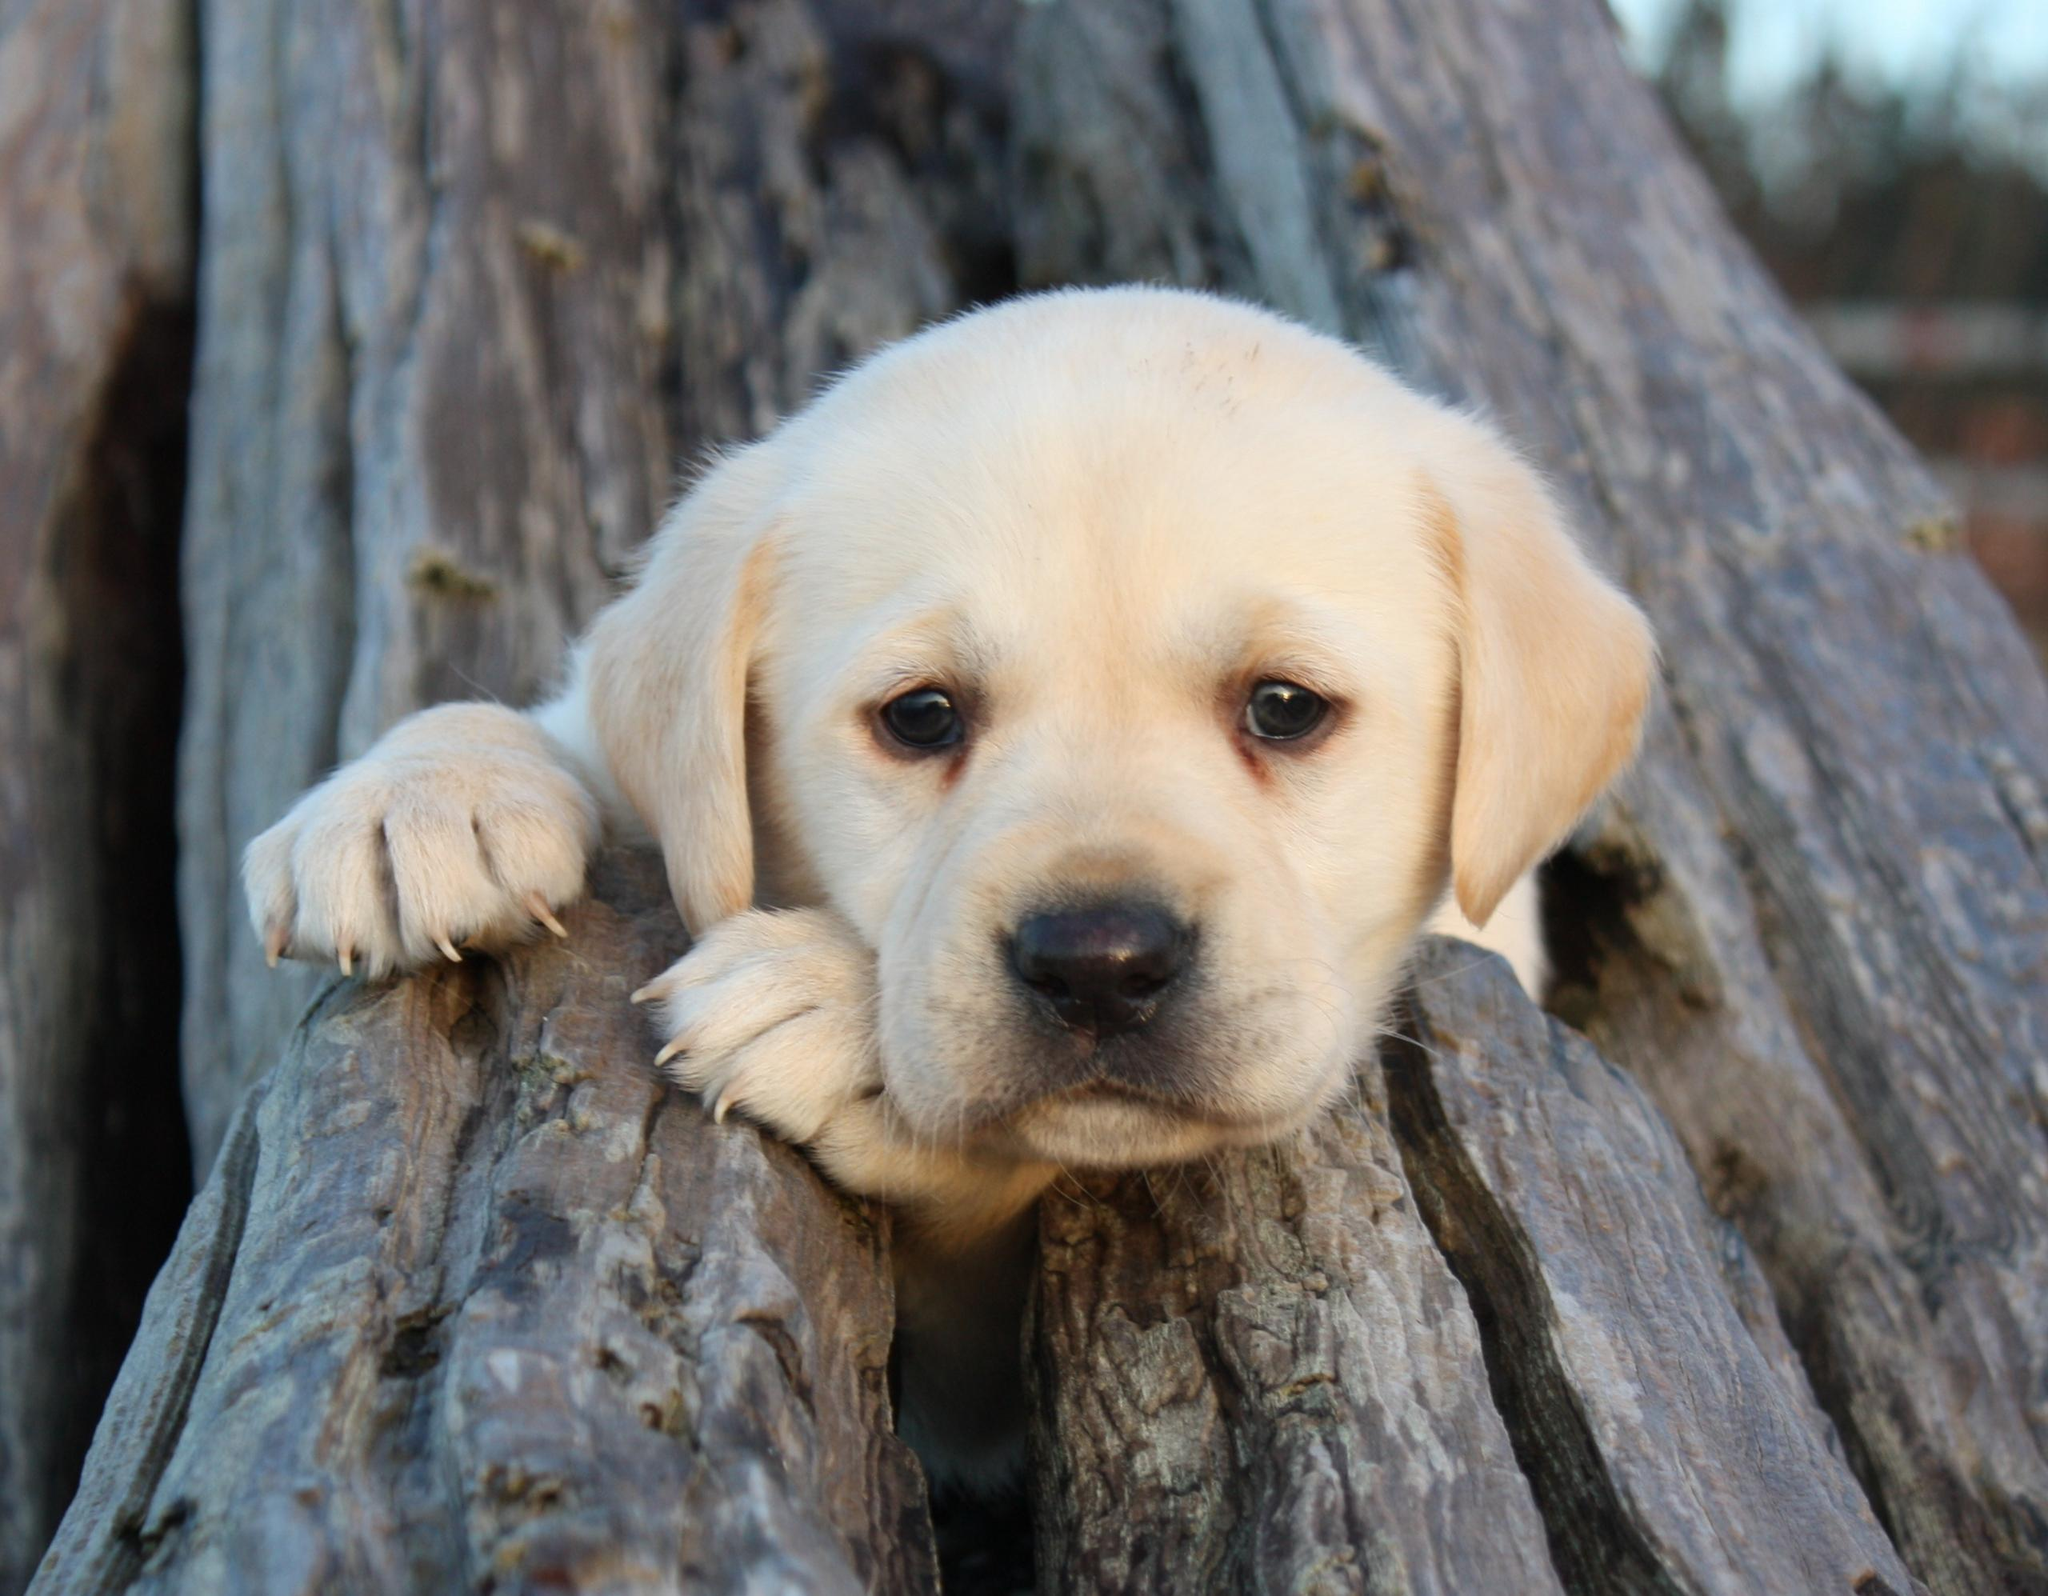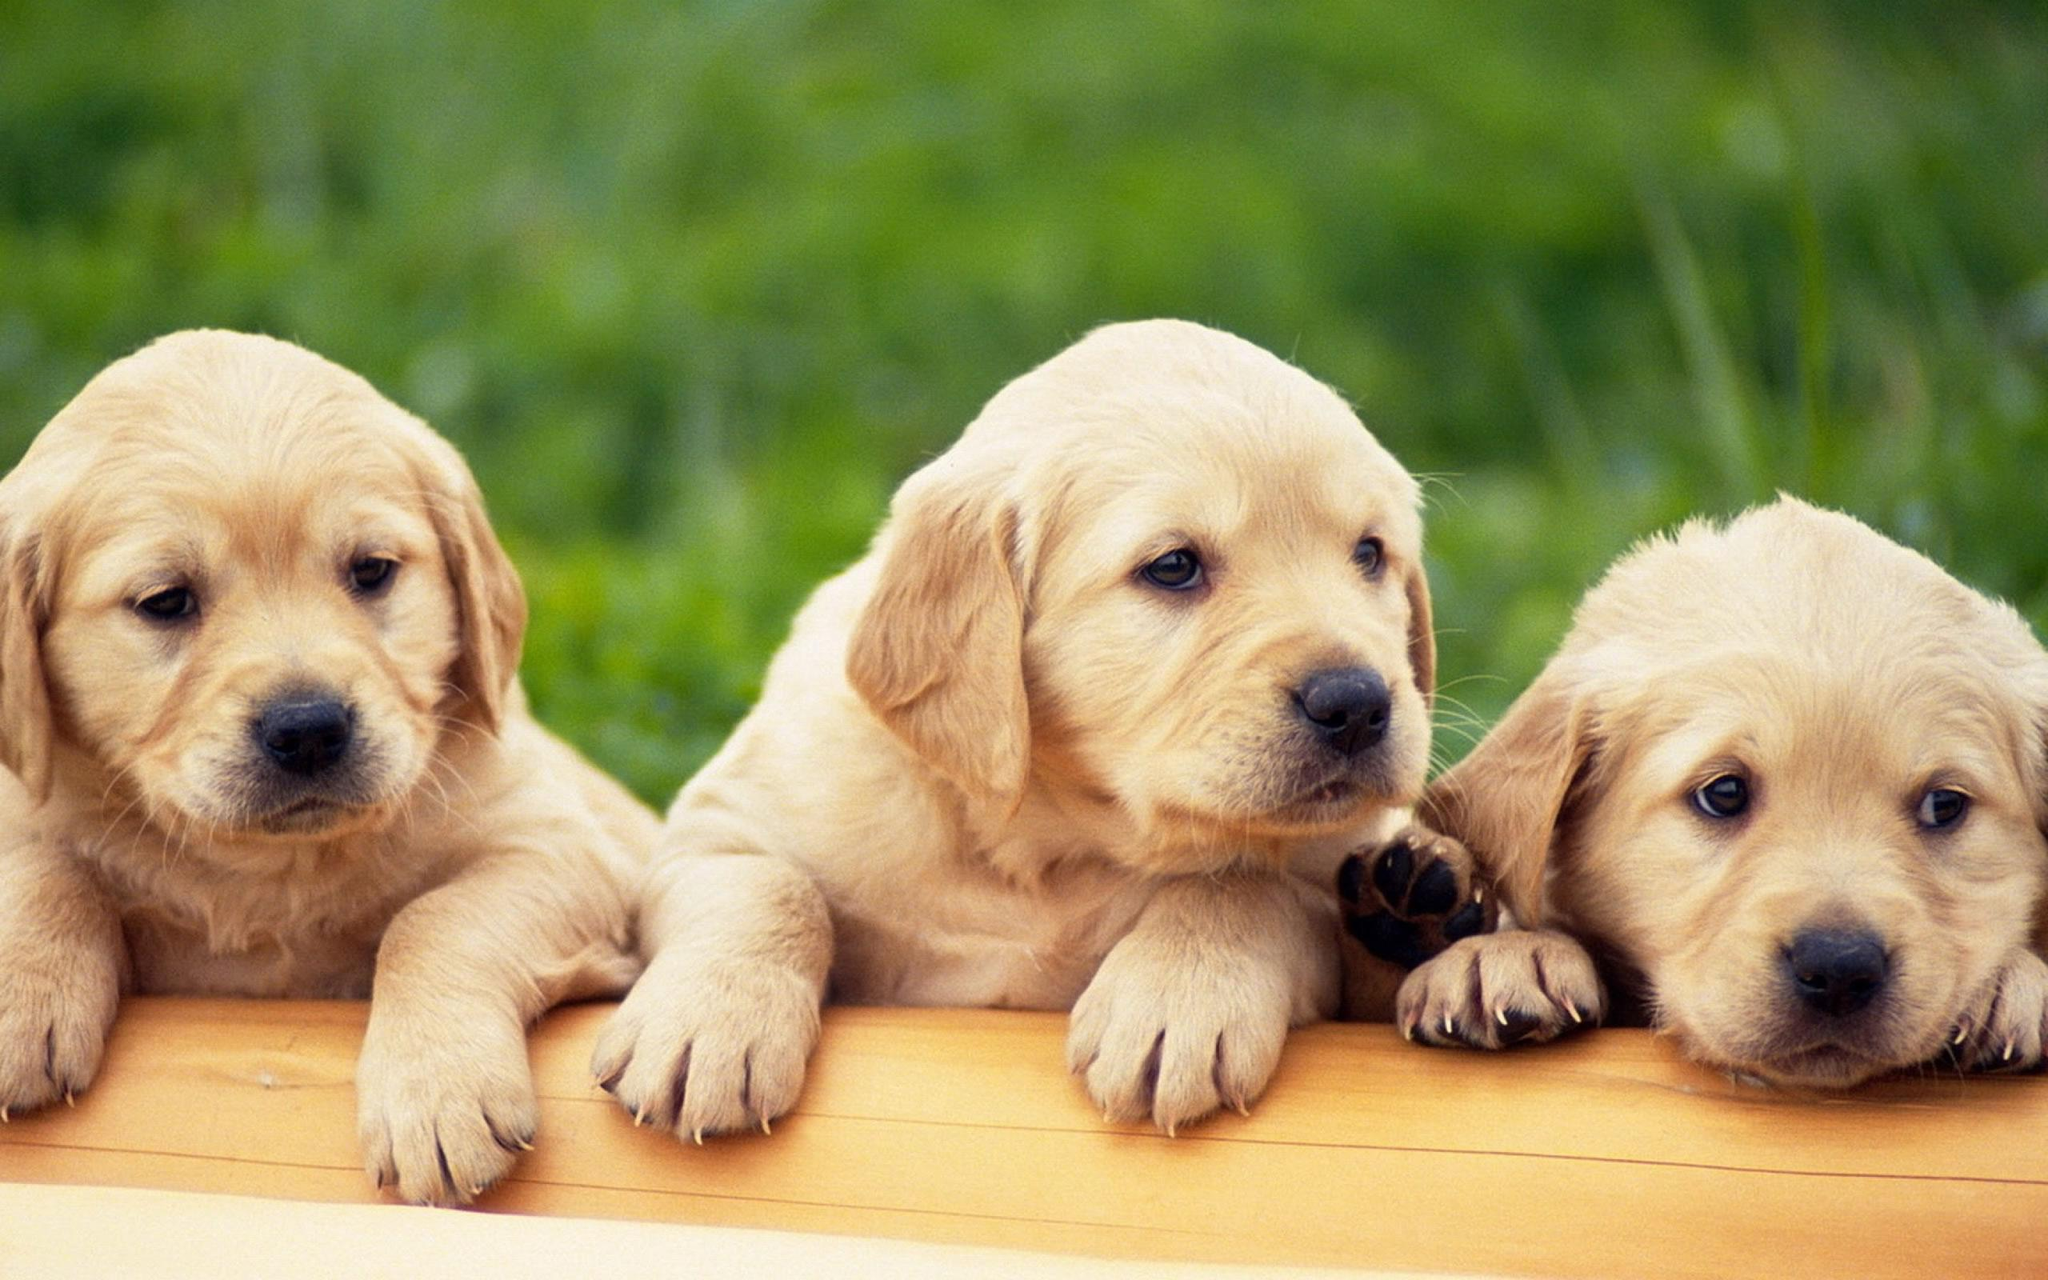The first image is the image on the left, the second image is the image on the right. Assess this claim about the two images: "There are at least three dogs in the right image.". Correct or not? Answer yes or no. Yes. The first image is the image on the left, the second image is the image on the right. Examine the images to the left and right. Is the description "Atleast 4 dogs total" accurate? Answer yes or no. Yes. 